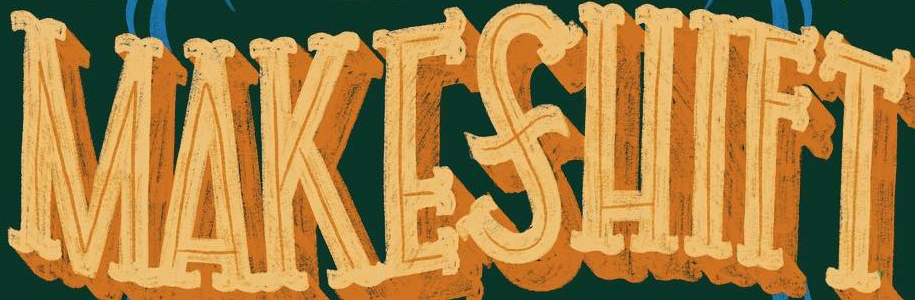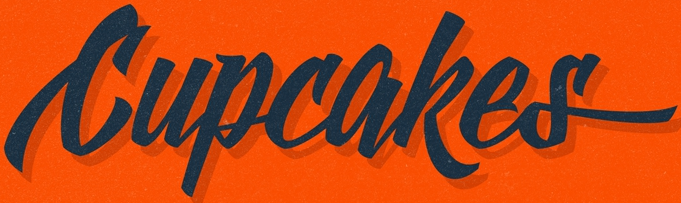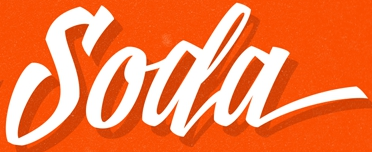What text appears in these images from left to right, separated by a semicolon? MAKESHIFT; Cupcakes; Soda 